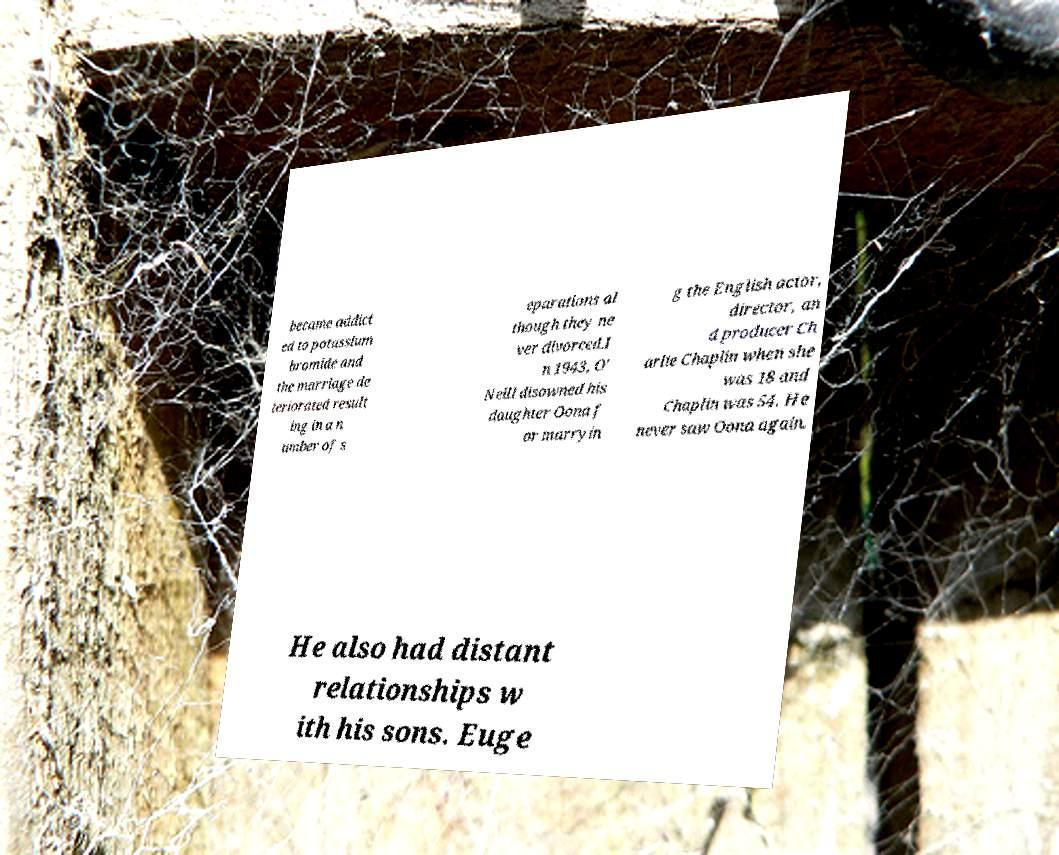Can you accurately transcribe the text from the provided image for me? became addict ed to potassium bromide and the marriage de teriorated result ing in a n umber of s eparations al though they ne ver divorced.I n 1943, O' Neill disowned his daughter Oona f or marryin g the English actor, director, an d producer Ch arlie Chaplin when she was 18 and Chaplin was 54. He never saw Oona again. He also had distant relationships w ith his sons. Euge 